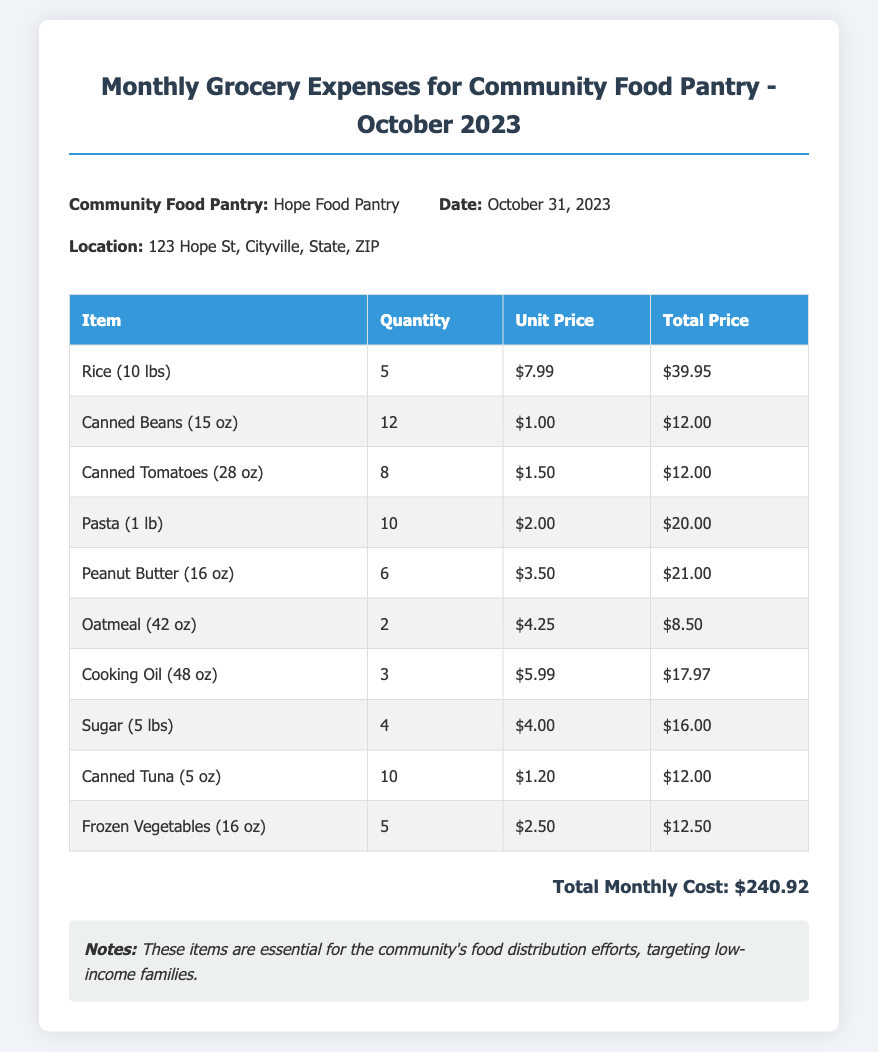What is the name of the community food pantry? The name of the community food pantry is mentioned at the top of the document.
Answer: Hope Food Pantry What is the total monthly cost? The total monthly cost is indicated at the bottom of the document.
Answer: $240.92 How many quantities of Canned Tuna were purchased? The quantity of Canned Tuna is stated in the itemized list of groceries.
Answer: 10 What is the unit price of Peanut Butter? The unit price for Peanut Butter is listed in the table of items.
Answer: $3.50 What is the address of the community food pantry? The address is provided in the header information section of the document.
Answer: 123 Hope St, Cityville, State, ZIP How many items were purchased in total? The total number of different items listed in the document can be counted.
Answer: 10 What was the date of the document? The date is specified in the header information section.
Answer: October 31, 2023 Which item had the highest total price? By reviewing the total prices in the itemized list, we determine which one is the highest.
Answer: Rice (10 lbs) What is indicated in the notes section? The notes section provides additional context about the items purchased.
Answer: These items are essential for the community's food distribution efforts, targeting low-income families What is the quantity of Cooking Oil purchased? The quantity of Cooking Oil can be found in the itemized table of groceries.
Answer: 3 